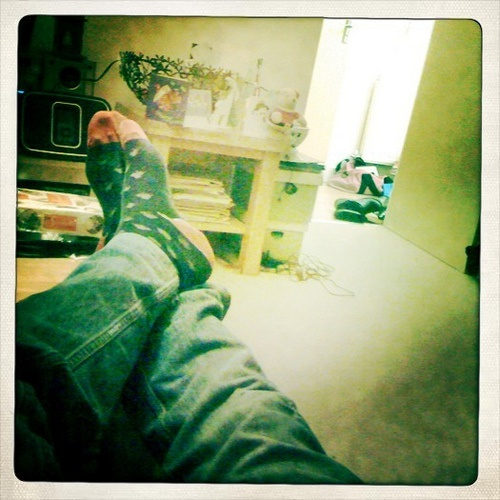Describe the objects in this image and their specific colors. I can see people in lightgray, black, darkgreen, and green tones and clock in lightgray, black, darkgreen, and green tones in this image. 